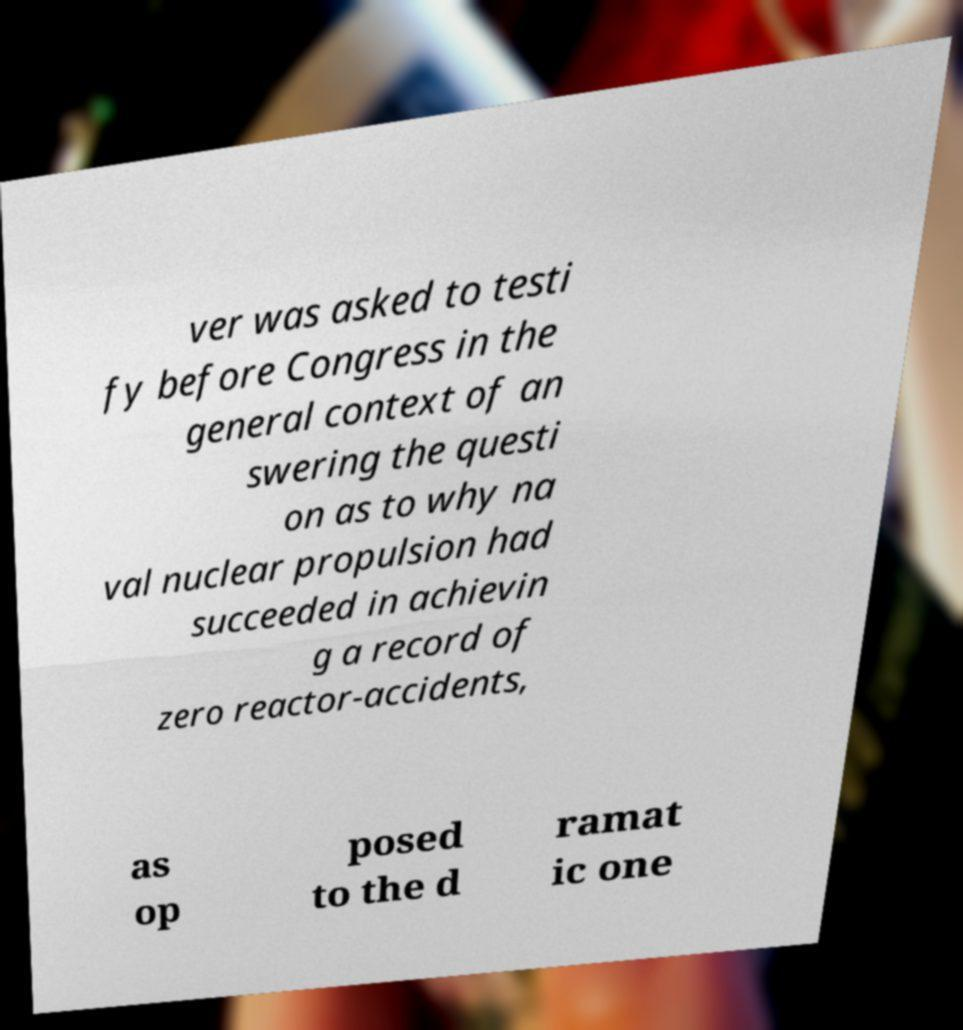Could you extract and type out the text from this image? ver was asked to testi fy before Congress in the general context of an swering the questi on as to why na val nuclear propulsion had succeeded in achievin g a record of zero reactor-accidents, as op posed to the d ramat ic one 